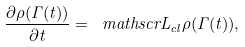Convert formula to latex. <formula><loc_0><loc_0><loc_500><loc_500>\frac { \partial \rho ( \Gamma ( t ) ) } { \partial t } = \ m a t h s c r { L } _ { c l } \rho ( \Gamma ( t ) ) ,</formula> 